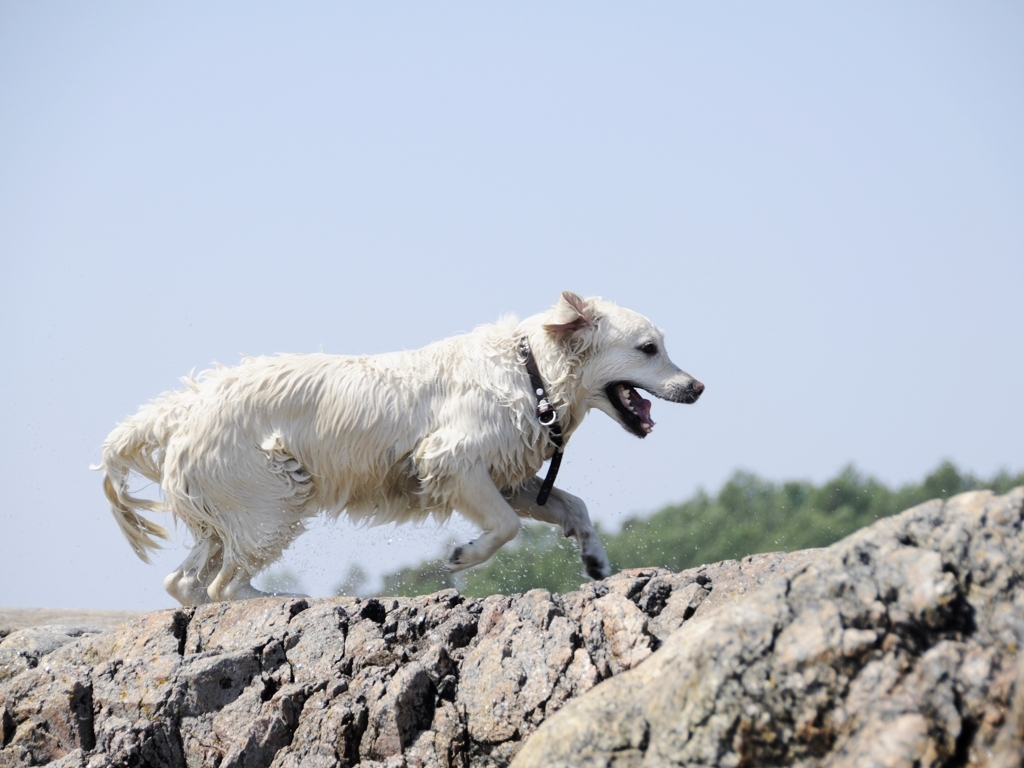Is there any overexposure in the image? After carefully examining the image, it seems that there are no areas that are significantly overexposed. The highlights in the image, such as the light reflecting off the dog’s fur and the sunlit rocks, are well within an acceptable range, showcasing details without any significant loss of information. This indicates that the dynamic range of the image is well managed, with no visible signs of overexposure. 